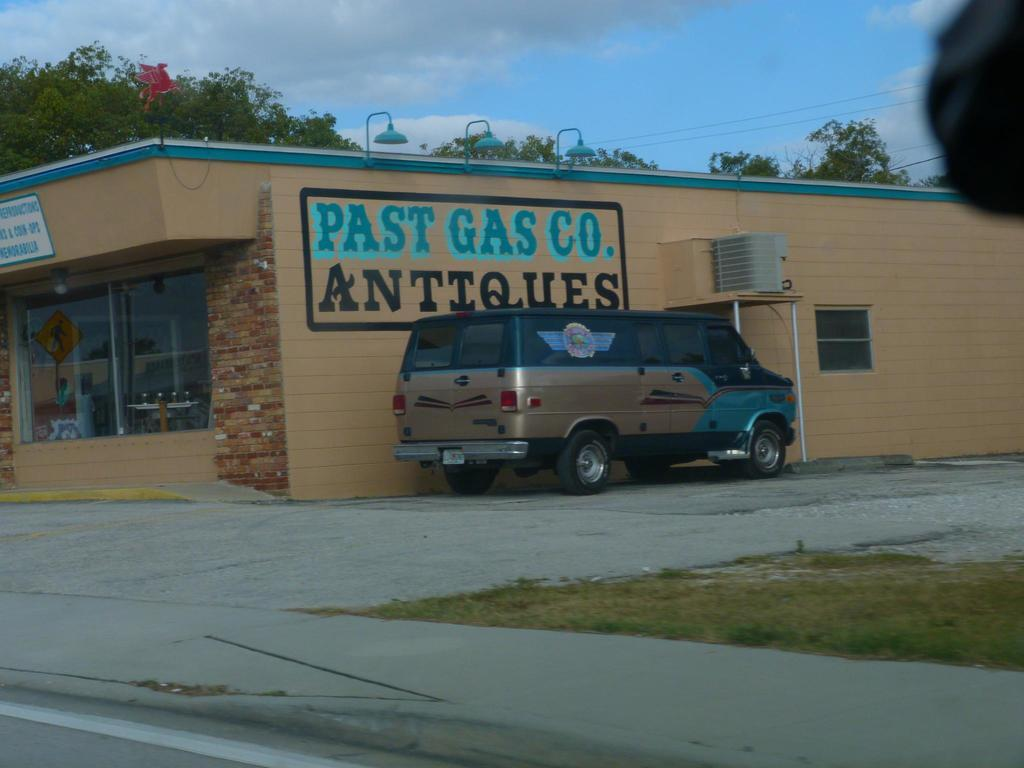Provide a one-sentence caption for the provided image. A building that has Pasta Gas Co. on it. 